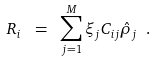<formula> <loc_0><loc_0><loc_500><loc_500>R _ { i } \ = \ \sum _ { j = 1 } ^ { M } \xi _ { j } C _ { i j } \hat { \rho } _ { j } \ .</formula> 